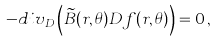Convert formula to latex. <formula><loc_0><loc_0><loc_500><loc_500>- d i v _ { D } \left ( \widetilde { B } ( r , \theta ) D f ( r , \theta ) \right ) = 0 \, ,</formula> 